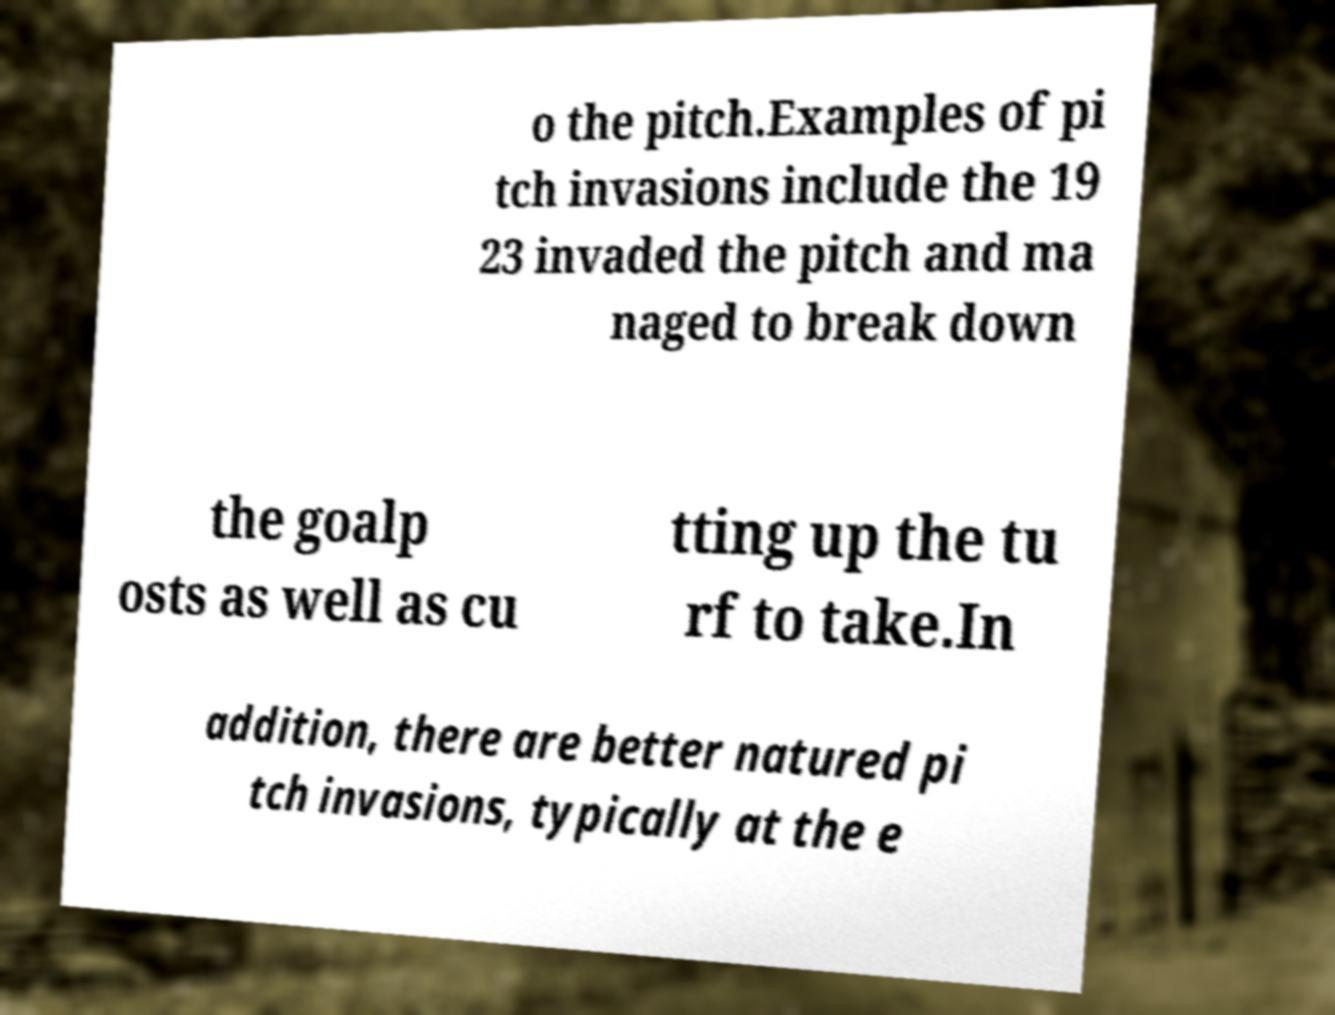For documentation purposes, I need the text within this image transcribed. Could you provide that? o the pitch.Examples of pi tch invasions include the 19 23 invaded the pitch and ma naged to break down the goalp osts as well as cu tting up the tu rf to take.In addition, there are better natured pi tch invasions, typically at the e 